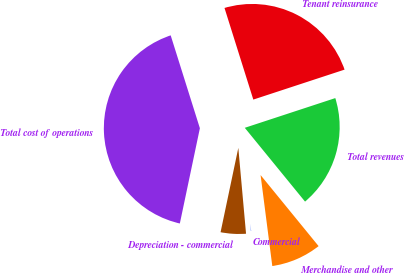<chart> <loc_0><loc_0><loc_500><loc_500><pie_chart><fcel>Commercial<fcel>Merchandise and other<fcel>Total revenues<fcel>Tenant reinsurance<fcel>Total cost of operations<fcel>Depreciation - commercial<nl><fcel>0.61%<fcel>8.86%<fcel>19.15%<fcel>24.8%<fcel>41.85%<fcel>4.73%<nl></chart> 